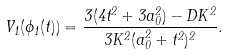<formula> <loc_0><loc_0><loc_500><loc_500>V _ { 1 } ( \phi _ { 1 } ( t ) ) = \frac { 3 ( 4 t ^ { 2 } + 3 a _ { 0 } ^ { 2 } ) - D K ^ { 2 } } { 3 K ^ { 2 } ( a _ { 0 } ^ { 2 } + t ^ { 2 } ) ^ { 2 } } .</formula> 